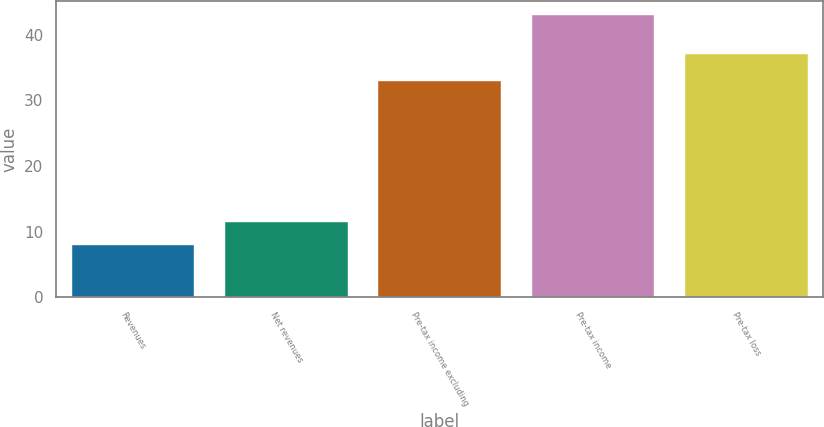Convert chart. <chart><loc_0><loc_0><loc_500><loc_500><bar_chart><fcel>Revenues<fcel>Net revenues<fcel>Pre-tax income excluding<fcel>Pre-tax income<fcel>Pre-tax loss<nl><fcel>8<fcel>11.5<fcel>33<fcel>43<fcel>37<nl></chart> 